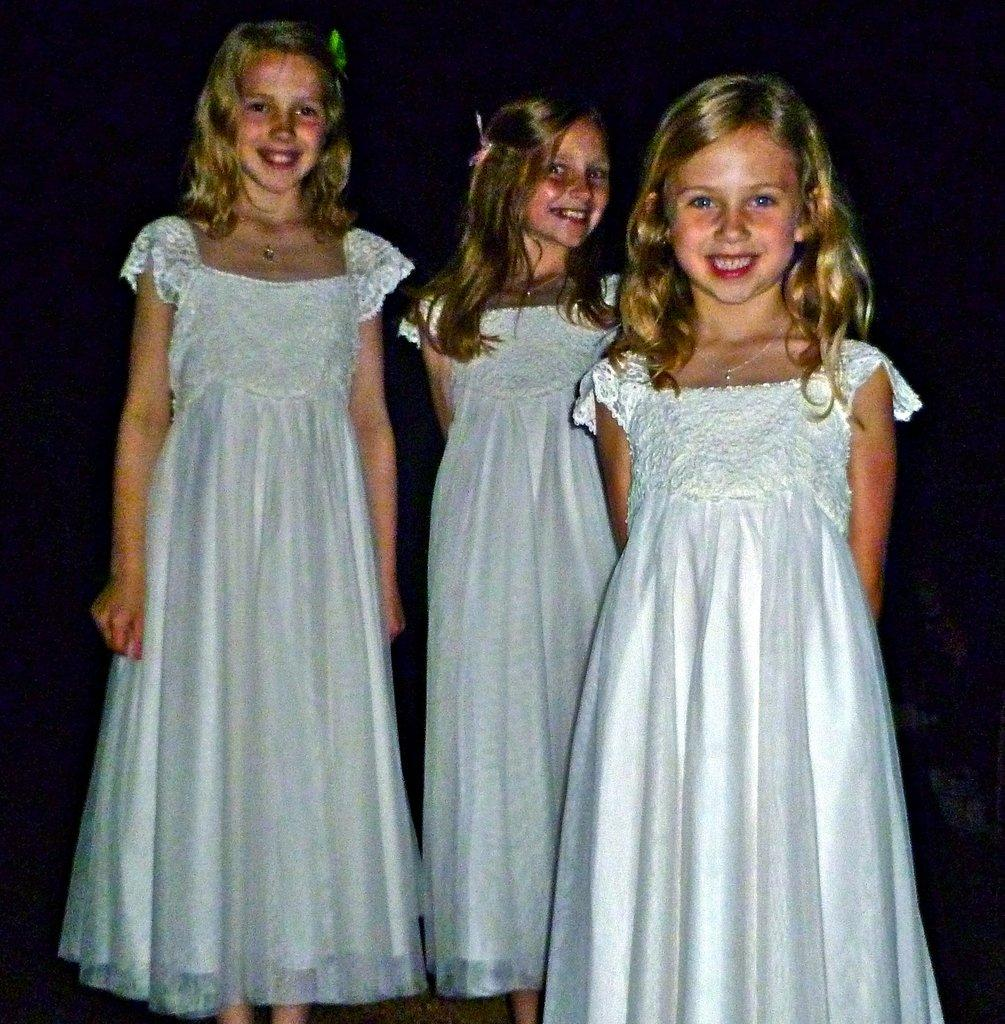How many kids are in the image? There are three kids in the image. What are the kids doing in the image? The kids are standing and smiling. What color are the dresses the kids are wearing? The kids are wearing white color dresses. What can be observed about the background of the image? The background of the image is dark. Can you see the dad's toe in the image? There is no dad or toe present in the image; it only features three kids. 